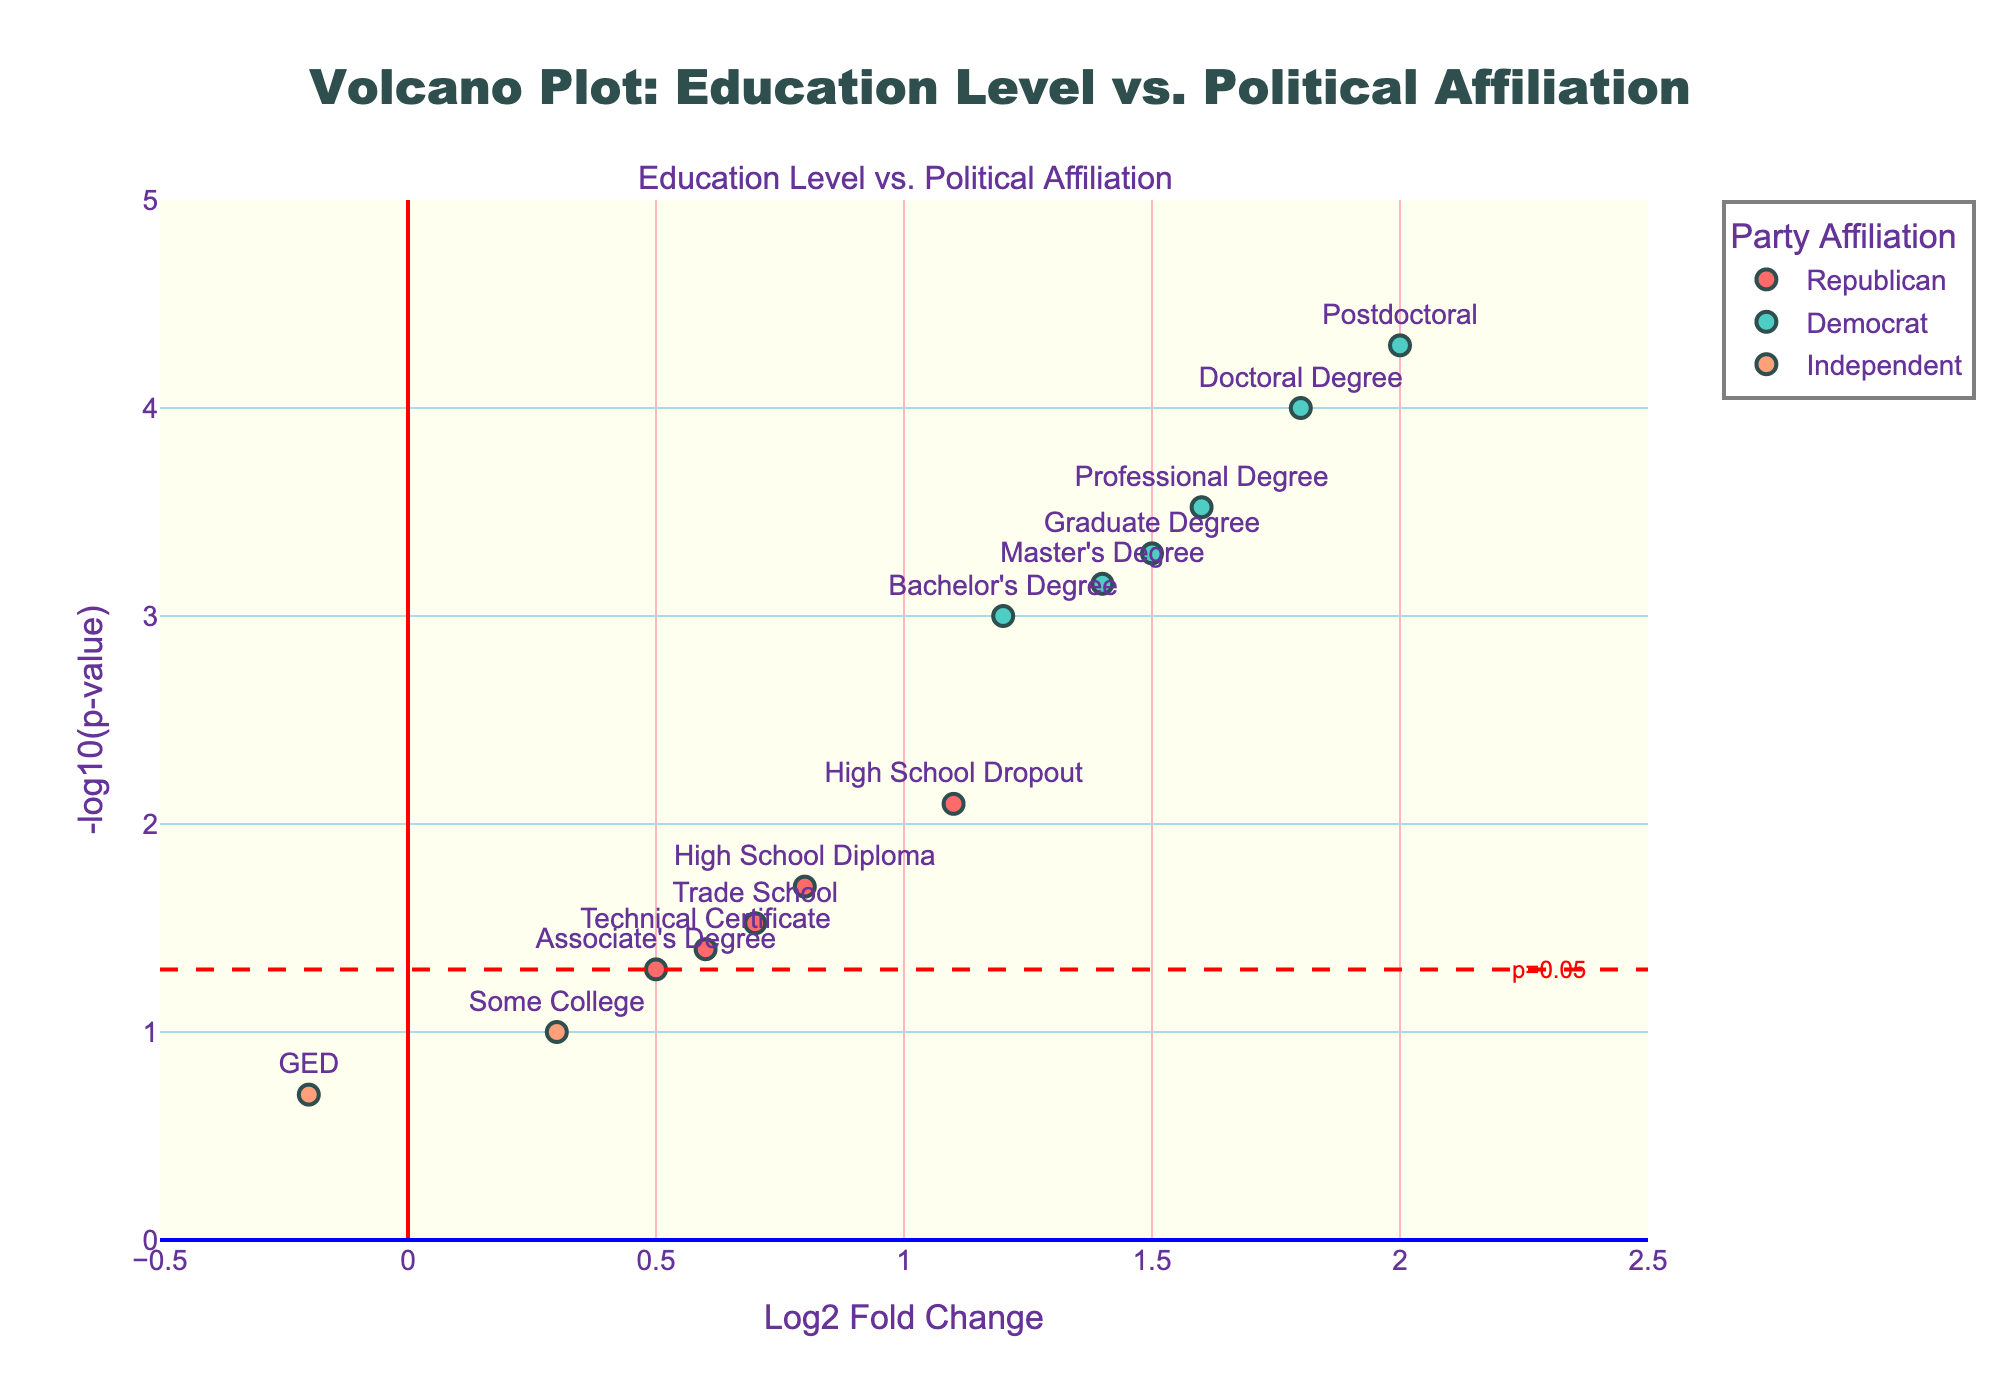What is the title of the plot? The title of the plot is displayed at the top of the figure. It indicates what the plot is about. Here, it reads "Volcano Plot: Education Level vs. Political Affiliation".
Answer: Volcano Plot: Education Level vs. Political Affiliation Which education level shows the highest Log2 Fold Change? To find the highest Log2 Fold Change, look at the x-axis values and identify the highest point. The "Postdoctoral" degree corresponds to the highest value on the x-axis (Log2FC = 2.0).
Answer: Postdoctoral How many data points fall below the p-value threshold of 0.05? A dashed line at -log10(p-value) = -log10(0.05) acts as a threshold marker. Count the points above this dashed line lightly annotated as "p=0.05". There are 11 such points.
Answer: 11 Which party affiliation has the most data points? Each color in the plot represents a different party affiliation. Count the data points for each color. The Democrats (light blue) have the most data points.
Answer: Democrats Of the education levels represented by the Independents, which one has a negative Log2 Fold Change? Look for data points labeled as "Independent" (orange) and check the x-axis to see if the value is below 0. "GED" falls under Independent and has a Log2 Fold Change of -0.2.
Answer: GED Which education levels show a significant correlation (p-value < 0.05) with party affiliation? Significant correlation is indicated by points above the p = 0.05 threshold line. List all education levels at these points: "High School Diploma", "Bachelor's Degree", "Graduate Degree", "Associate's Degree", "Doctoral Degree", "Trade School", "High School Dropout", "Professional Degree", "Master's Degree", "Technical Certificate", "Postdoctoral".
Answer: High School Diploma, Bachelor's Degree, Graduate Degree, Associate's Degree, Doctoral Degree, Trade School, High School Dropout, Professional Degree, Master's Degree, Technical Certificate, Postdoctoral Compare the Log2 Fold Change of "Master's Degree" and "High School Diploma". Which is higher? Find both education levels on the plot and compare their x-axis values. "Master's Degree" has a Log2 Fold Change of 1.4, whereas "High School Diploma" has 0.8. The Master's Degree is higher.
Answer: Master's Degree Arrange the top three education levels with the lowest p-values. Identify the points with the lowest y-axis values (highest -log10(p-value)). These values are "Postdoctoral" (2e-5), "Doctoral Degree" (1e-4), and "Professional Degree" (3e-4).
Answer: Postdoctoral, Doctoral Degree, Professional Degree 